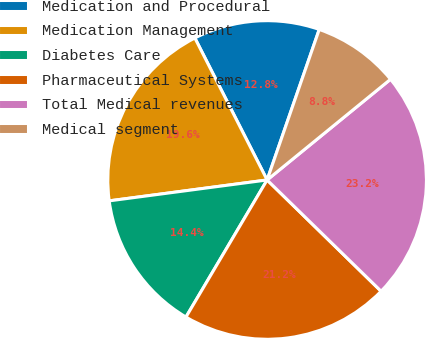<chart> <loc_0><loc_0><loc_500><loc_500><pie_chart><fcel>Medication and Procedural<fcel>Medication Management<fcel>Diabetes Care<fcel>Pharmaceutical Systems<fcel>Total Medical revenues<fcel>Medical segment<nl><fcel>12.8%<fcel>19.6%<fcel>14.4%<fcel>21.2%<fcel>23.2%<fcel>8.8%<nl></chart> 